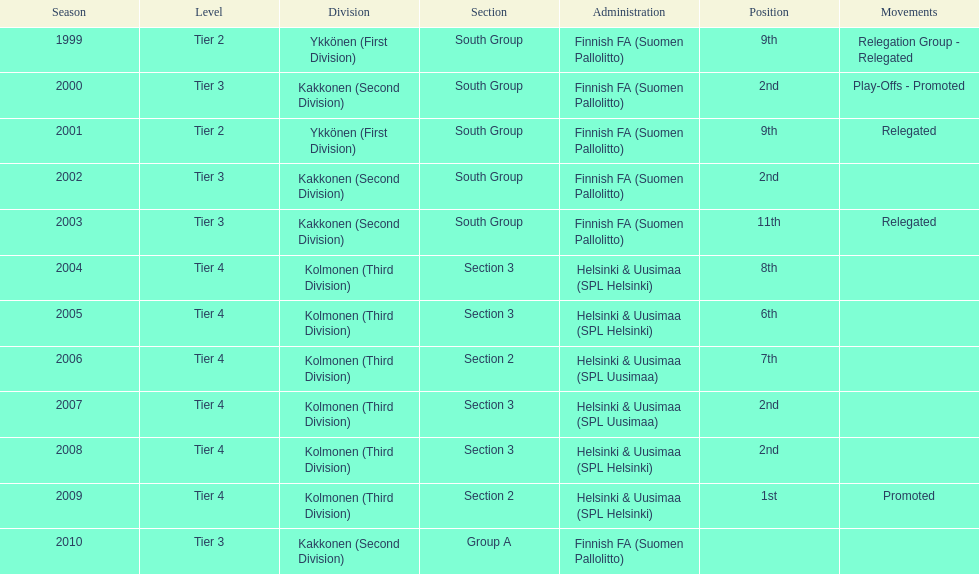In which subdivision were they primarily, part 3 or 2? 3. 